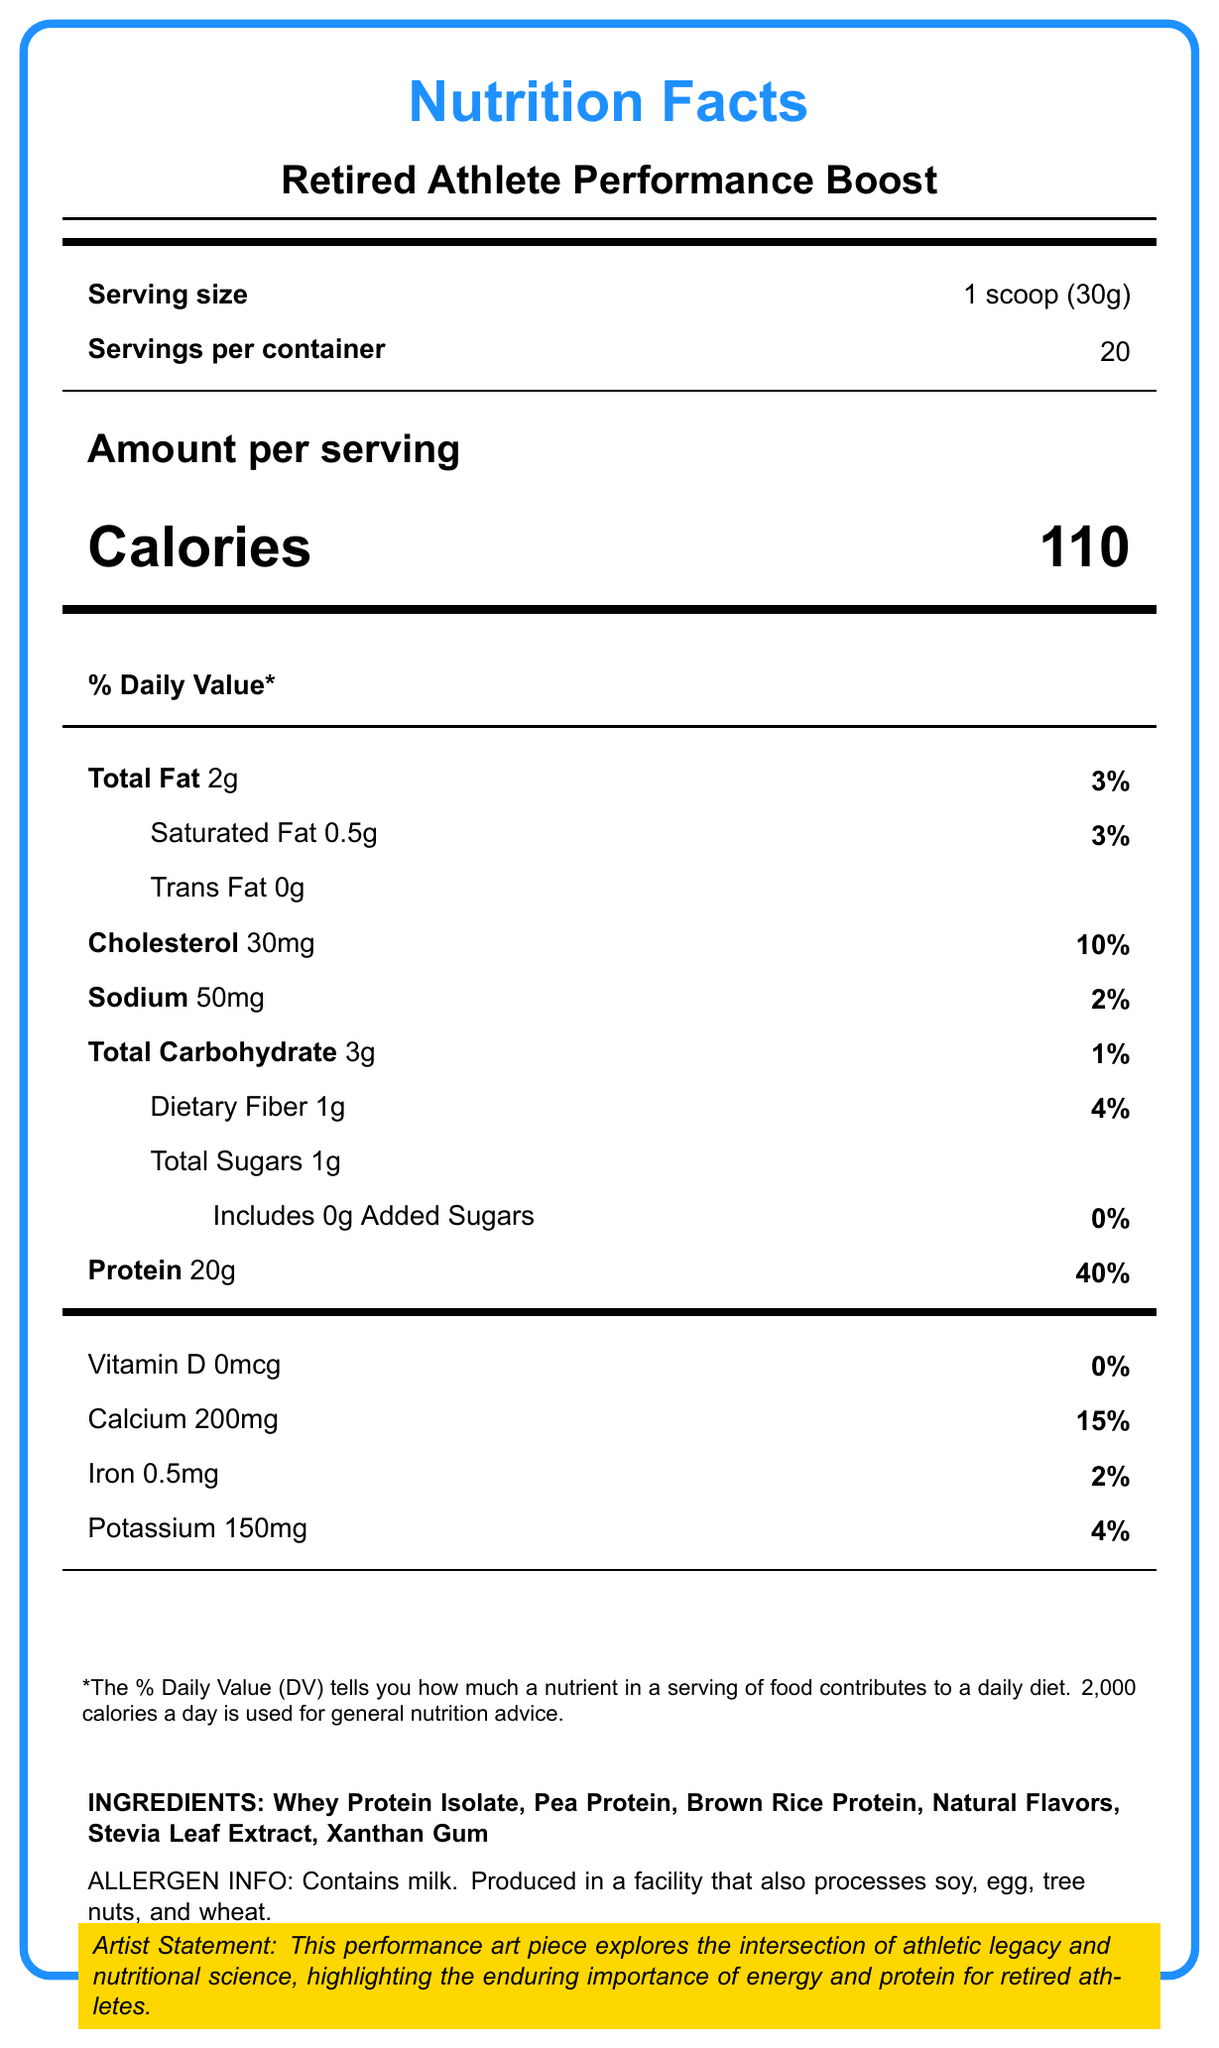what is the serving size? The serving size is mentioned directly under the "Serving size" heading on the Nutrition Facts Label.
Answer: 1 scoop (30g) how many servings are there per container? This information is listed next to "Servings per container" on the label.
Answer: 20 how many calories are in one serving? The number of calories per serving is displayed prominently next to "Calories" under the "Amount per serving" section.
Answer: 110 how much protein is in one serving? The amount of protein per serving is specified under the "Protein" heading.
Answer: 20g what is the percent daily value of protein per serving? The percent daily value for protein is indicated next to the amount of protein per serving.
Answer: 40% how much calcium is in one serving? The amount of calcium per serving is listed under the "Calcium" heading.
Answer: 200mg which ingredient is listed first? The first ingredient listed is found in the "INGREDIENTS" section at the bottom of the label.
Answer: Whey Protein Isolate what is the amount of sodium in one serving? The amount of sodium per serving is listed under the "Sodium" heading.
Answer: 50mg how many grams of saturated fat are in one serving? The amount of saturated fat per serving is mentioned next to "Saturated Fat" under the "Total Fat" section.
Answer: 0.5g what is the percent daily value for total carbohydrate per serving? The percent daily value for total carbohydrate is indicated under the "Total Carbohydrate" heading.
Answer: 1% how much dietary fiber is in one serving? A. 2g B. 1g C. 3g D. 4g The amount of dietary fiber per serving is listed as 1g.
Answer: B what is the correct amount of cholesterol per serving based on the label? i. 10g ii. 5mg iii. 0mg iv. 30mg The amount of cholesterol per serving is listed as 30mg.
Answer: iv does the product contain any trans fat? The label lists "Trans Fat 0g" indicating there is no trans fat in the product.
Answer: No does the product contain added sugars? The label lists "Includes 0g Added Sugars", indicating there are no added sugars.
Answer: No summarize the main idea of this document. This summary includes key details about the content and purpose of the Nutrition Facts Label and its context in a performance art piece.
Answer: The document provides the Nutrition Facts Label for a product named "Retired Athlete Performance Boost", detailing serving size, calories, macronutrients, vitamins, and minerals. It highlights the protein and energy content intended to benefit retired athletes and includes an artist statement about the intersection of athletic legacy and nutritional science. The label also lists ingredients, allergen information, and provides an artist statement and performance art elements inspired by retired athletes. which athlete inspired this product? A. Michael Jordan B. Lionel Messi C. Cristiano Ronaldo The document mentions multiple inspiring athletes including Michael Jordan, Serena Williams, Usain Bolt, Simone Biles, and Roger Federer, but does not specify that one particular athlete solely inspired the product.
Answer: Cannot be determined are there any vitamins listed in the Nutrition Facts? Vitamin D is listed, though it is given as 0mcg, indicating its absence, but it is still a vitamin listed on the Nutrition Facts Label.
Answer: Yes 